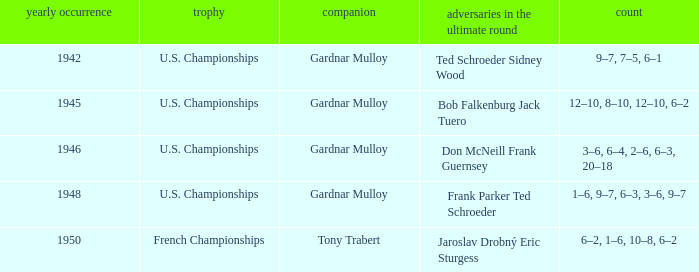Which opponents in the u.s. championships played after 1945 and had a score of 3–6, 6–4, 2–6, 6–3, 20–18? Don McNeill Frank Guernsey. 